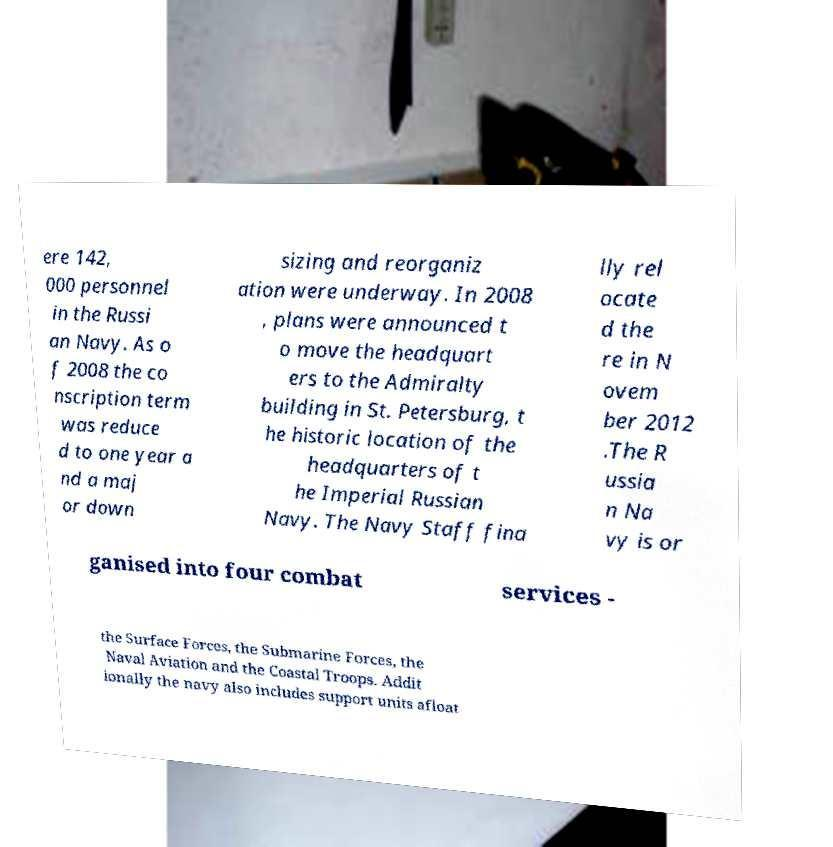There's text embedded in this image that I need extracted. Can you transcribe it verbatim? ere 142, 000 personnel in the Russi an Navy. As o f 2008 the co nscription term was reduce d to one year a nd a maj or down sizing and reorganiz ation were underway. In 2008 , plans were announced t o move the headquart ers to the Admiralty building in St. Petersburg, t he historic location of the headquarters of t he Imperial Russian Navy. The Navy Staff fina lly rel ocate d the re in N ovem ber 2012 .The R ussia n Na vy is or ganised into four combat services - the Surface Forces, the Submarine Forces, the Naval Aviation and the Coastal Troops. Addit ionally the navy also includes support units afloat 